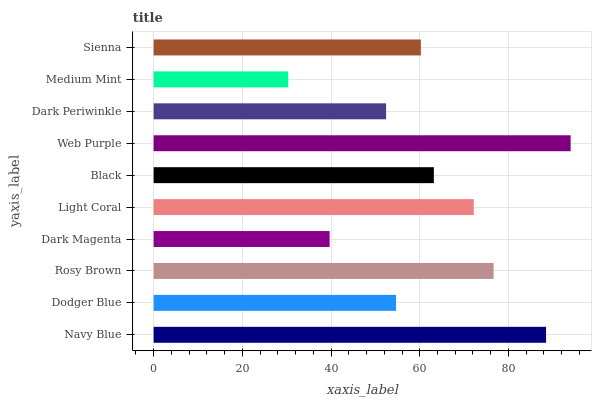Is Medium Mint the minimum?
Answer yes or no. Yes. Is Web Purple the maximum?
Answer yes or no. Yes. Is Dodger Blue the minimum?
Answer yes or no. No. Is Dodger Blue the maximum?
Answer yes or no. No. Is Navy Blue greater than Dodger Blue?
Answer yes or no. Yes. Is Dodger Blue less than Navy Blue?
Answer yes or no. Yes. Is Dodger Blue greater than Navy Blue?
Answer yes or no. No. Is Navy Blue less than Dodger Blue?
Answer yes or no. No. Is Black the high median?
Answer yes or no. Yes. Is Sienna the low median?
Answer yes or no. Yes. Is Medium Mint the high median?
Answer yes or no. No. Is Dark Magenta the low median?
Answer yes or no. No. 